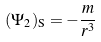Convert formula to latex. <formula><loc_0><loc_0><loc_500><loc_500>( \Psi _ { 2 } ) _ { \mathrm S } = - \frac { m } { r ^ { 3 } }</formula> 